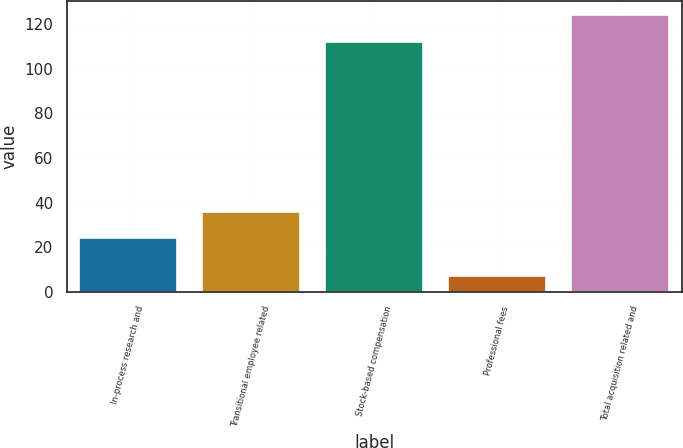<chart> <loc_0><loc_0><loc_500><loc_500><bar_chart><fcel>In-process research and<fcel>Transitional employee related<fcel>Stock-based compensation<fcel>Professional fees<fcel>Total acquisition related and<nl><fcel>24<fcel>35.7<fcel>112<fcel>7<fcel>124<nl></chart> 